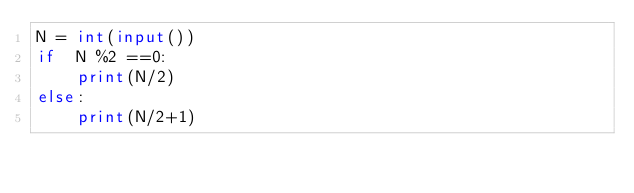<code> <loc_0><loc_0><loc_500><loc_500><_Python_>N = int(input())
if  N %2 ==0:
    print(N/2)
else:
    print(N/2+1)</code> 